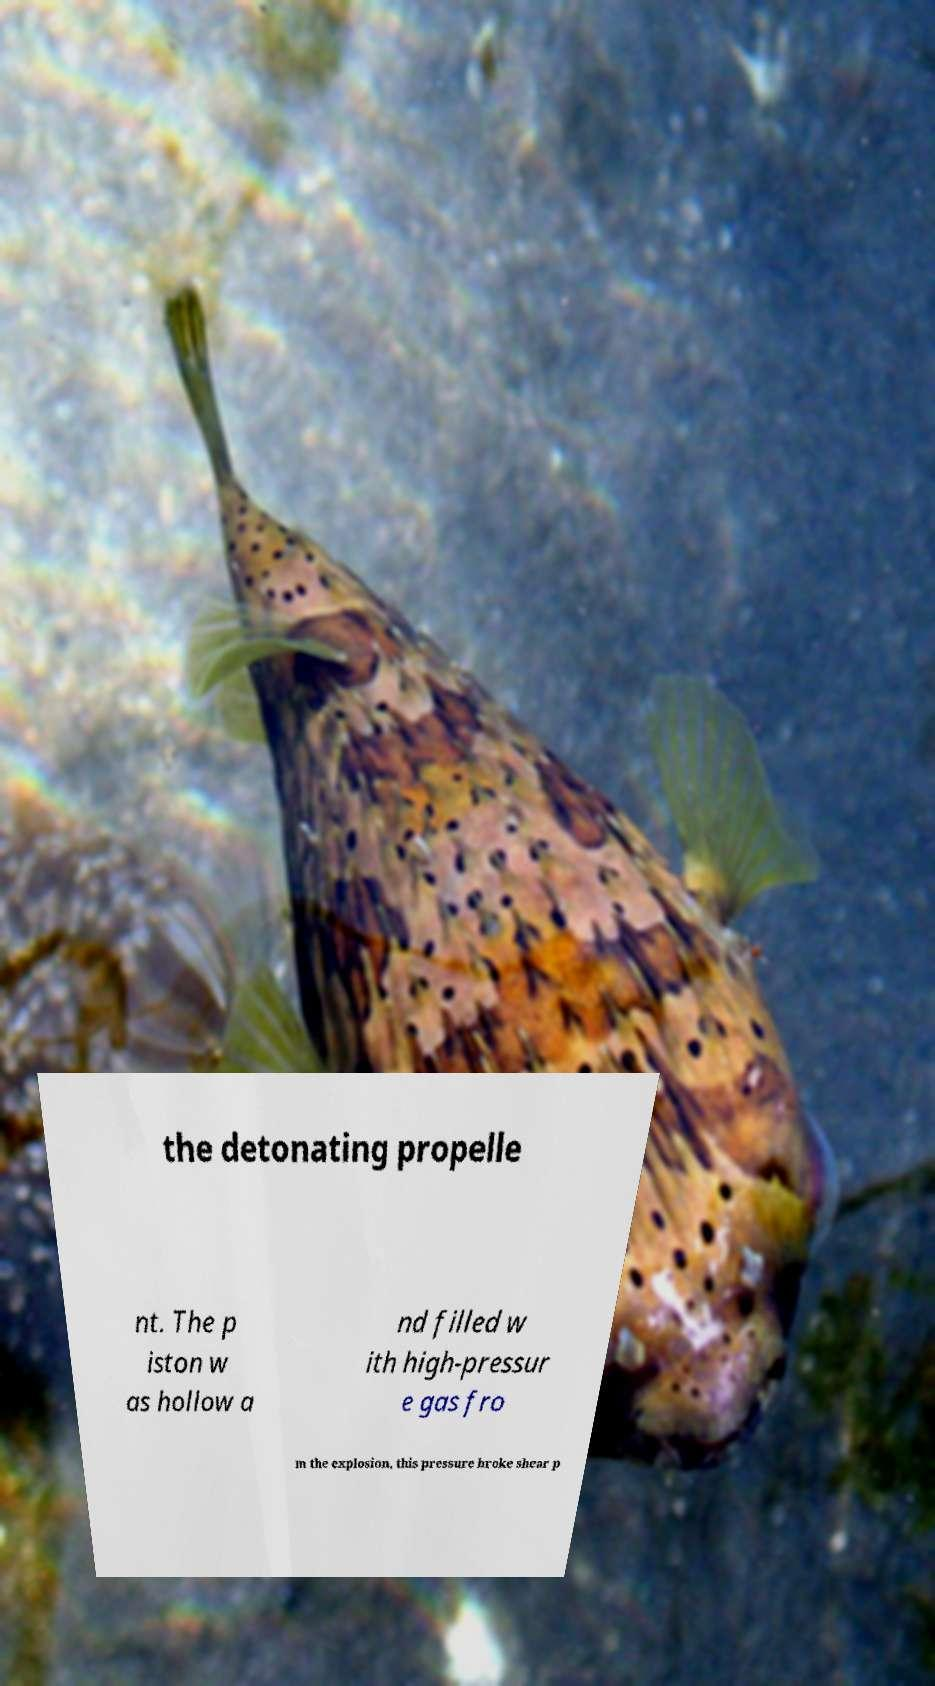Please read and relay the text visible in this image. What does it say? the detonating propelle nt. The p iston w as hollow a nd filled w ith high-pressur e gas fro m the explosion, this pressure broke shear p 